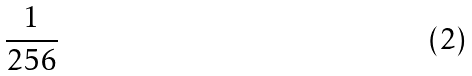Convert formula to latex. <formula><loc_0><loc_0><loc_500><loc_500>\frac { 1 } { 2 5 6 }</formula> 